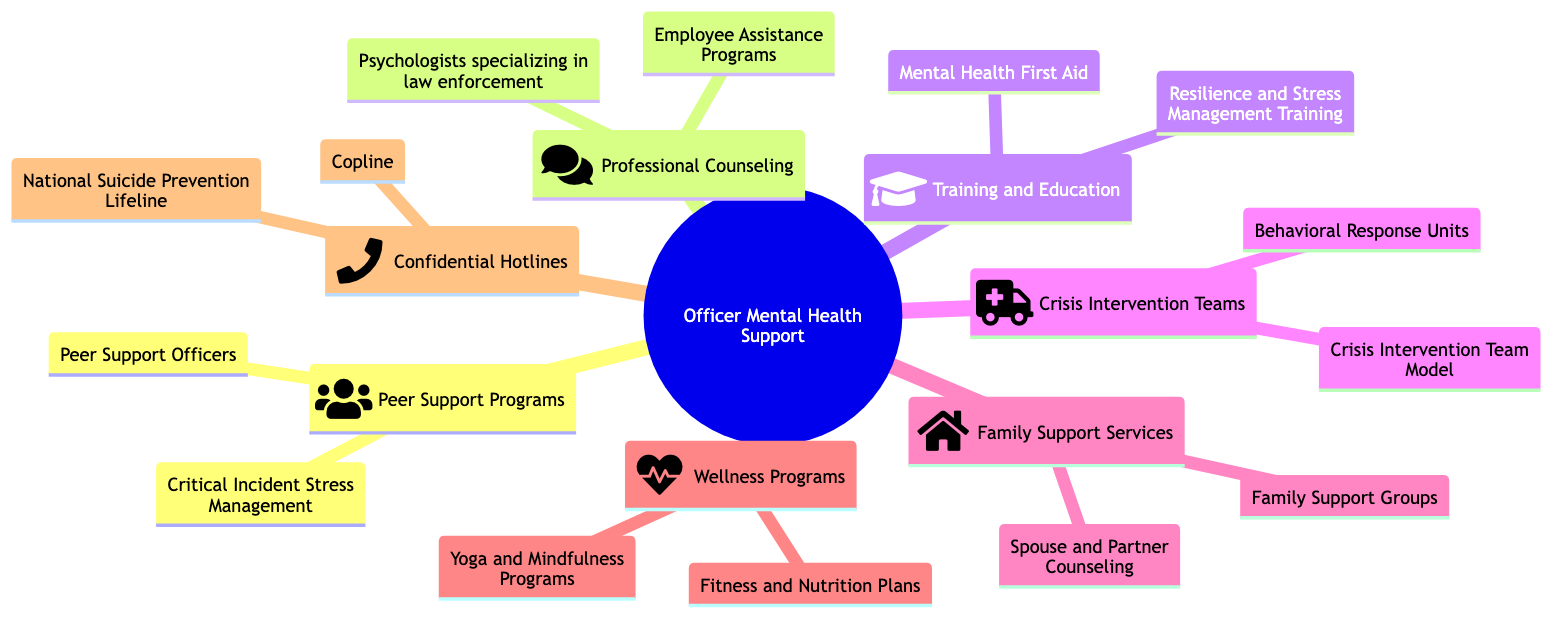What are the examples listed under Peer Support Programs? The diagram lists examples under "Peer Support Programs" as: "Critical Incident Stress Management (CISM)" and "Peer Support Officers (PSOs)".
Answer: Critical Incident Stress Management (CISM), Peer Support Officers (PSOs) How many main categories are there in the Officer Mental Health Support mind map? The mind map has seven main categories, each representing a different aspect of officer mental health support.
Answer: 7 What type of professionals are included in Professional Counseling? The "Professional Counseling" category refers to "licensed mental health professionals for confidential support" as specified in the description.
Answer: licensed mental health professionals What is the purpose of Crisis Intervention Teams? The description states that Crisis Intervention Teams are "specialized units trained to handle mental health crises."
Answer: handle mental health crises Which category includes support services for the families of officers? The category labeled "Family Support Services" specifically addresses resources and support for officers' families.
Answer: Family Support Services How do Wellness Programs contribute to officer well-being? Wellness Programs are described as focusing on "physical and mental well-being," indicating a holistic approach to officer health.
Answer: physical and mental well-being What examples fall under the Confidential Hotlines category? The examples provided under "Confidential Hotlines" are "Copline" and "National Suicide Prevention Lifeline."
Answer: Copline, National Suicide Prevention Lifeline Which training course aims to educate officers about mental health? The "Training and Education" category includes "Mental Health First Aid (MHFA)" as a specific course for officer education on mental health.
Answer: Mental Health First Aid (MHFA) How does the mind map structure categorize Officer Mental Health Support visually? The mind map visually categorizes "Officer Mental Health Support" with a central node connected to various categories, each represented with an icon.
Answer: central node with various categories 